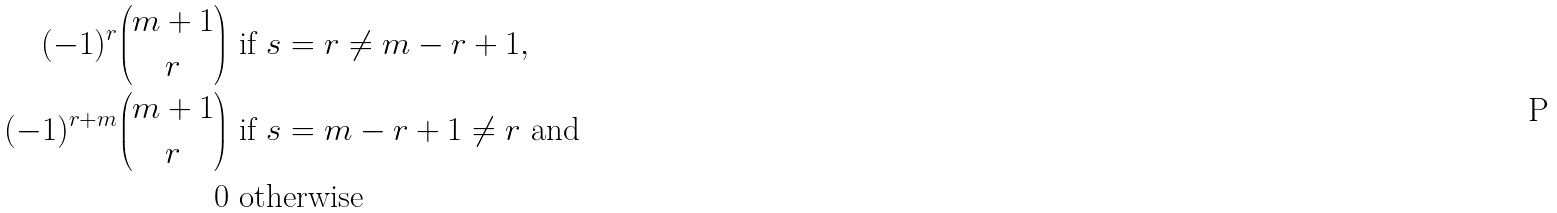<formula> <loc_0><loc_0><loc_500><loc_500>( - 1 ) ^ { r } \binom { m + 1 } { r } & \text { if } s = r \neq m - r + 1 , \\ ( - 1 ) ^ { r + m } \binom { m + 1 } { r } & \text { if } s = m - r + 1 \neq r \text { and} \\ 0 & \text { otherwise}</formula> 